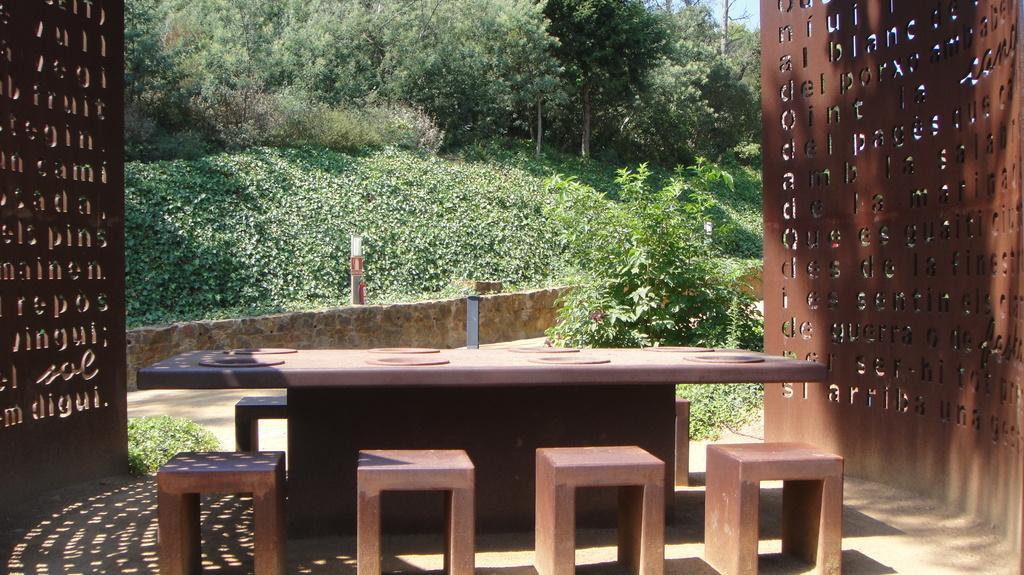Can you describe this image briefly? In this image I can see a table and few chairs. In the background I can see few trees. On either side of the image there is a wall. 